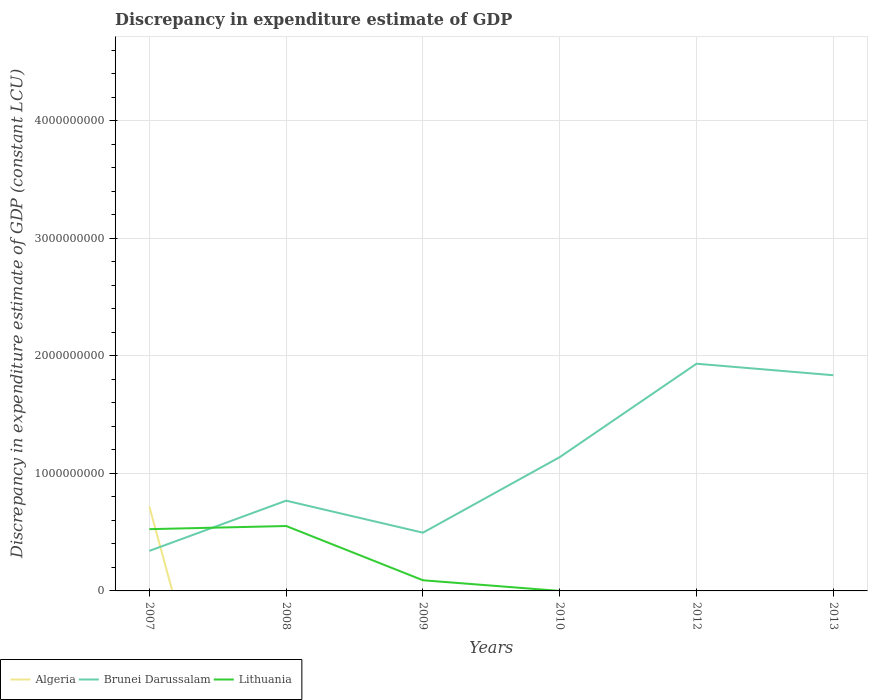How many different coloured lines are there?
Your answer should be very brief. 3. Does the line corresponding to Lithuania intersect with the line corresponding to Brunei Darussalam?
Your response must be concise. Yes. Is the number of lines equal to the number of legend labels?
Your answer should be compact. No. Across all years, what is the maximum discrepancy in expenditure estimate of GDP in Brunei Darussalam?
Make the answer very short. 3.41e+08. What is the total discrepancy in expenditure estimate of GDP in Brunei Darussalam in the graph?
Your response must be concise. -1.49e+09. What is the difference between the highest and the second highest discrepancy in expenditure estimate of GDP in Lithuania?
Offer a terse response. 5.52e+08. What is the difference between the highest and the lowest discrepancy in expenditure estimate of GDP in Lithuania?
Provide a short and direct response. 2. Is the discrepancy in expenditure estimate of GDP in Brunei Darussalam strictly greater than the discrepancy in expenditure estimate of GDP in Lithuania over the years?
Give a very brief answer. No. How many lines are there?
Ensure brevity in your answer.  3. What is the difference between two consecutive major ticks on the Y-axis?
Ensure brevity in your answer.  1.00e+09. Are the values on the major ticks of Y-axis written in scientific E-notation?
Offer a terse response. No. Does the graph contain grids?
Provide a short and direct response. Yes. Where does the legend appear in the graph?
Your response must be concise. Bottom left. How many legend labels are there?
Make the answer very short. 3. How are the legend labels stacked?
Your answer should be compact. Horizontal. What is the title of the graph?
Your answer should be very brief. Discrepancy in expenditure estimate of GDP. Does "Moldova" appear as one of the legend labels in the graph?
Your answer should be compact. No. What is the label or title of the X-axis?
Make the answer very short. Years. What is the label or title of the Y-axis?
Offer a terse response. Discrepancy in expenditure estimate of GDP (constant LCU). What is the Discrepancy in expenditure estimate of GDP (constant LCU) of Algeria in 2007?
Provide a short and direct response. 7.17e+08. What is the Discrepancy in expenditure estimate of GDP (constant LCU) of Brunei Darussalam in 2007?
Ensure brevity in your answer.  3.41e+08. What is the Discrepancy in expenditure estimate of GDP (constant LCU) in Lithuania in 2007?
Ensure brevity in your answer.  5.26e+08. What is the Discrepancy in expenditure estimate of GDP (constant LCU) in Brunei Darussalam in 2008?
Make the answer very short. 7.68e+08. What is the Discrepancy in expenditure estimate of GDP (constant LCU) of Lithuania in 2008?
Keep it short and to the point. 5.52e+08. What is the Discrepancy in expenditure estimate of GDP (constant LCU) of Brunei Darussalam in 2009?
Offer a terse response. 4.96e+08. What is the Discrepancy in expenditure estimate of GDP (constant LCU) of Lithuania in 2009?
Give a very brief answer. 9.07e+07. What is the Discrepancy in expenditure estimate of GDP (constant LCU) of Algeria in 2010?
Offer a very short reply. 0. What is the Discrepancy in expenditure estimate of GDP (constant LCU) in Brunei Darussalam in 2010?
Your answer should be very brief. 1.14e+09. What is the Discrepancy in expenditure estimate of GDP (constant LCU) in Algeria in 2012?
Offer a very short reply. 0. What is the Discrepancy in expenditure estimate of GDP (constant LCU) of Brunei Darussalam in 2012?
Offer a very short reply. 1.93e+09. What is the Discrepancy in expenditure estimate of GDP (constant LCU) in Lithuania in 2012?
Your answer should be compact. 0. What is the Discrepancy in expenditure estimate of GDP (constant LCU) of Algeria in 2013?
Provide a succinct answer. 0. What is the Discrepancy in expenditure estimate of GDP (constant LCU) of Brunei Darussalam in 2013?
Give a very brief answer. 1.84e+09. What is the Discrepancy in expenditure estimate of GDP (constant LCU) of Lithuania in 2013?
Your answer should be compact. 0. Across all years, what is the maximum Discrepancy in expenditure estimate of GDP (constant LCU) of Algeria?
Offer a terse response. 7.17e+08. Across all years, what is the maximum Discrepancy in expenditure estimate of GDP (constant LCU) in Brunei Darussalam?
Offer a very short reply. 1.93e+09. Across all years, what is the maximum Discrepancy in expenditure estimate of GDP (constant LCU) of Lithuania?
Provide a succinct answer. 5.52e+08. Across all years, what is the minimum Discrepancy in expenditure estimate of GDP (constant LCU) in Brunei Darussalam?
Provide a short and direct response. 3.41e+08. Across all years, what is the minimum Discrepancy in expenditure estimate of GDP (constant LCU) in Lithuania?
Provide a short and direct response. 0. What is the total Discrepancy in expenditure estimate of GDP (constant LCU) in Algeria in the graph?
Offer a terse response. 7.17e+08. What is the total Discrepancy in expenditure estimate of GDP (constant LCU) in Brunei Darussalam in the graph?
Your response must be concise. 6.51e+09. What is the total Discrepancy in expenditure estimate of GDP (constant LCU) of Lithuania in the graph?
Give a very brief answer. 1.17e+09. What is the difference between the Discrepancy in expenditure estimate of GDP (constant LCU) in Brunei Darussalam in 2007 and that in 2008?
Provide a succinct answer. -4.27e+08. What is the difference between the Discrepancy in expenditure estimate of GDP (constant LCU) in Lithuania in 2007 and that in 2008?
Make the answer very short. -2.67e+07. What is the difference between the Discrepancy in expenditure estimate of GDP (constant LCU) in Brunei Darussalam in 2007 and that in 2009?
Make the answer very short. -1.55e+08. What is the difference between the Discrepancy in expenditure estimate of GDP (constant LCU) of Lithuania in 2007 and that in 2009?
Your answer should be compact. 4.35e+08. What is the difference between the Discrepancy in expenditure estimate of GDP (constant LCU) in Brunei Darussalam in 2007 and that in 2010?
Keep it short and to the point. -7.98e+08. What is the difference between the Discrepancy in expenditure estimate of GDP (constant LCU) of Lithuania in 2007 and that in 2010?
Keep it short and to the point. 5.26e+08. What is the difference between the Discrepancy in expenditure estimate of GDP (constant LCU) of Brunei Darussalam in 2007 and that in 2012?
Give a very brief answer. -1.59e+09. What is the difference between the Discrepancy in expenditure estimate of GDP (constant LCU) of Brunei Darussalam in 2007 and that in 2013?
Offer a very short reply. -1.49e+09. What is the difference between the Discrepancy in expenditure estimate of GDP (constant LCU) in Brunei Darussalam in 2008 and that in 2009?
Provide a short and direct response. 2.72e+08. What is the difference between the Discrepancy in expenditure estimate of GDP (constant LCU) in Lithuania in 2008 and that in 2009?
Keep it short and to the point. 4.62e+08. What is the difference between the Discrepancy in expenditure estimate of GDP (constant LCU) in Brunei Darussalam in 2008 and that in 2010?
Offer a very short reply. -3.71e+08. What is the difference between the Discrepancy in expenditure estimate of GDP (constant LCU) of Lithuania in 2008 and that in 2010?
Make the answer very short. 5.52e+08. What is the difference between the Discrepancy in expenditure estimate of GDP (constant LCU) of Brunei Darussalam in 2008 and that in 2012?
Offer a terse response. -1.17e+09. What is the difference between the Discrepancy in expenditure estimate of GDP (constant LCU) in Brunei Darussalam in 2008 and that in 2013?
Make the answer very short. -1.07e+09. What is the difference between the Discrepancy in expenditure estimate of GDP (constant LCU) of Brunei Darussalam in 2009 and that in 2010?
Your response must be concise. -6.43e+08. What is the difference between the Discrepancy in expenditure estimate of GDP (constant LCU) in Lithuania in 2009 and that in 2010?
Give a very brief answer. 9.07e+07. What is the difference between the Discrepancy in expenditure estimate of GDP (constant LCU) of Brunei Darussalam in 2009 and that in 2012?
Offer a terse response. -1.44e+09. What is the difference between the Discrepancy in expenditure estimate of GDP (constant LCU) in Brunei Darussalam in 2009 and that in 2013?
Offer a terse response. -1.34e+09. What is the difference between the Discrepancy in expenditure estimate of GDP (constant LCU) of Brunei Darussalam in 2010 and that in 2012?
Offer a very short reply. -7.95e+08. What is the difference between the Discrepancy in expenditure estimate of GDP (constant LCU) of Brunei Darussalam in 2010 and that in 2013?
Keep it short and to the point. -6.97e+08. What is the difference between the Discrepancy in expenditure estimate of GDP (constant LCU) of Brunei Darussalam in 2012 and that in 2013?
Keep it short and to the point. 9.79e+07. What is the difference between the Discrepancy in expenditure estimate of GDP (constant LCU) in Algeria in 2007 and the Discrepancy in expenditure estimate of GDP (constant LCU) in Brunei Darussalam in 2008?
Ensure brevity in your answer.  -5.05e+07. What is the difference between the Discrepancy in expenditure estimate of GDP (constant LCU) in Algeria in 2007 and the Discrepancy in expenditure estimate of GDP (constant LCU) in Lithuania in 2008?
Provide a succinct answer. 1.65e+08. What is the difference between the Discrepancy in expenditure estimate of GDP (constant LCU) of Brunei Darussalam in 2007 and the Discrepancy in expenditure estimate of GDP (constant LCU) of Lithuania in 2008?
Provide a short and direct response. -2.12e+08. What is the difference between the Discrepancy in expenditure estimate of GDP (constant LCU) of Algeria in 2007 and the Discrepancy in expenditure estimate of GDP (constant LCU) of Brunei Darussalam in 2009?
Ensure brevity in your answer.  2.22e+08. What is the difference between the Discrepancy in expenditure estimate of GDP (constant LCU) in Algeria in 2007 and the Discrepancy in expenditure estimate of GDP (constant LCU) in Lithuania in 2009?
Provide a short and direct response. 6.27e+08. What is the difference between the Discrepancy in expenditure estimate of GDP (constant LCU) in Brunei Darussalam in 2007 and the Discrepancy in expenditure estimate of GDP (constant LCU) in Lithuania in 2009?
Your answer should be compact. 2.50e+08. What is the difference between the Discrepancy in expenditure estimate of GDP (constant LCU) in Algeria in 2007 and the Discrepancy in expenditure estimate of GDP (constant LCU) in Brunei Darussalam in 2010?
Your answer should be compact. -4.21e+08. What is the difference between the Discrepancy in expenditure estimate of GDP (constant LCU) in Algeria in 2007 and the Discrepancy in expenditure estimate of GDP (constant LCU) in Lithuania in 2010?
Give a very brief answer. 7.17e+08. What is the difference between the Discrepancy in expenditure estimate of GDP (constant LCU) in Brunei Darussalam in 2007 and the Discrepancy in expenditure estimate of GDP (constant LCU) in Lithuania in 2010?
Your response must be concise. 3.41e+08. What is the difference between the Discrepancy in expenditure estimate of GDP (constant LCU) of Algeria in 2007 and the Discrepancy in expenditure estimate of GDP (constant LCU) of Brunei Darussalam in 2012?
Your answer should be compact. -1.22e+09. What is the difference between the Discrepancy in expenditure estimate of GDP (constant LCU) of Algeria in 2007 and the Discrepancy in expenditure estimate of GDP (constant LCU) of Brunei Darussalam in 2013?
Your response must be concise. -1.12e+09. What is the difference between the Discrepancy in expenditure estimate of GDP (constant LCU) of Brunei Darussalam in 2008 and the Discrepancy in expenditure estimate of GDP (constant LCU) of Lithuania in 2009?
Make the answer very short. 6.77e+08. What is the difference between the Discrepancy in expenditure estimate of GDP (constant LCU) in Brunei Darussalam in 2008 and the Discrepancy in expenditure estimate of GDP (constant LCU) in Lithuania in 2010?
Provide a succinct answer. 7.68e+08. What is the difference between the Discrepancy in expenditure estimate of GDP (constant LCU) in Brunei Darussalam in 2009 and the Discrepancy in expenditure estimate of GDP (constant LCU) in Lithuania in 2010?
Offer a terse response. 4.95e+08. What is the average Discrepancy in expenditure estimate of GDP (constant LCU) in Algeria per year?
Offer a very short reply. 1.20e+08. What is the average Discrepancy in expenditure estimate of GDP (constant LCU) in Brunei Darussalam per year?
Offer a terse response. 1.09e+09. What is the average Discrepancy in expenditure estimate of GDP (constant LCU) of Lithuania per year?
Your answer should be compact. 1.95e+08. In the year 2007, what is the difference between the Discrepancy in expenditure estimate of GDP (constant LCU) of Algeria and Discrepancy in expenditure estimate of GDP (constant LCU) of Brunei Darussalam?
Keep it short and to the point. 3.77e+08. In the year 2007, what is the difference between the Discrepancy in expenditure estimate of GDP (constant LCU) in Algeria and Discrepancy in expenditure estimate of GDP (constant LCU) in Lithuania?
Provide a short and direct response. 1.92e+08. In the year 2007, what is the difference between the Discrepancy in expenditure estimate of GDP (constant LCU) in Brunei Darussalam and Discrepancy in expenditure estimate of GDP (constant LCU) in Lithuania?
Give a very brief answer. -1.85e+08. In the year 2008, what is the difference between the Discrepancy in expenditure estimate of GDP (constant LCU) in Brunei Darussalam and Discrepancy in expenditure estimate of GDP (constant LCU) in Lithuania?
Offer a terse response. 2.16e+08. In the year 2009, what is the difference between the Discrepancy in expenditure estimate of GDP (constant LCU) in Brunei Darussalam and Discrepancy in expenditure estimate of GDP (constant LCU) in Lithuania?
Offer a very short reply. 4.05e+08. In the year 2010, what is the difference between the Discrepancy in expenditure estimate of GDP (constant LCU) of Brunei Darussalam and Discrepancy in expenditure estimate of GDP (constant LCU) of Lithuania?
Give a very brief answer. 1.14e+09. What is the ratio of the Discrepancy in expenditure estimate of GDP (constant LCU) in Brunei Darussalam in 2007 to that in 2008?
Offer a terse response. 0.44. What is the ratio of the Discrepancy in expenditure estimate of GDP (constant LCU) in Lithuania in 2007 to that in 2008?
Offer a terse response. 0.95. What is the ratio of the Discrepancy in expenditure estimate of GDP (constant LCU) of Brunei Darussalam in 2007 to that in 2009?
Make the answer very short. 0.69. What is the ratio of the Discrepancy in expenditure estimate of GDP (constant LCU) of Lithuania in 2007 to that in 2009?
Ensure brevity in your answer.  5.8. What is the ratio of the Discrepancy in expenditure estimate of GDP (constant LCU) of Brunei Darussalam in 2007 to that in 2010?
Keep it short and to the point. 0.3. What is the ratio of the Discrepancy in expenditure estimate of GDP (constant LCU) in Lithuania in 2007 to that in 2010?
Keep it short and to the point. 5.26e+06. What is the ratio of the Discrepancy in expenditure estimate of GDP (constant LCU) of Brunei Darussalam in 2007 to that in 2012?
Give a very brief answer. 0.18. What is the ratio of the Discrepancy in expenditure estimate of GDP (constant LCU) in Brunei Darussalam in 2007 to that in 2013?
Make the answer very short. 0.19. What is the ratio of the Discrepancy in expenditure estimate of GDP (constant LCU) of Brunei Darussalam in 2008 to that in 2009?
Your response must be concise. 1.55. What is the ratio of the Discrepancy in expenditure estimate of GDP (constant LCU) in Lithuania in 2008 to that in 2009?
Offer a terse response. 6.09. What is the ratio of the Discrepancy in expenditure estimate of GDP (constant LCU) of Brunei Darussalam in 2008 to that in 2010?
Make the answer very short. 0.67. What is the ratio of the Discrepancy in expenditure estimate of GDP (constant LCU) in Lithuania in 2008 to that in 2010?
Offer a very short reply. 5.52e+06. What is the ratio of the Discrepancy in expenditure estimate of GDP (constant LCU) in Brunei Darussalam in 2008 to that in 2012?
Your response must be concise. 0.4. What is the ratio of the Discrepancy in expenditure estimate of GDP (constant LCU) in Brunei Darussalam in 2008 to that in 2013?
Your answer should be very brief. 0.42. What is the ratio of the Discrepancy in expenditure estimate of GDP (constant LCU) of Brunei Darussalam in 2009 to that in 2010?
Provide a succinct answer. 0.44. What is the ratio of the Discrepancy in expenditure estimate of GDP (constant LCU) of Lithuania in 2009 to that in 2010?
Ensure brevity in your answer.  9.07e+05. What is the ratio of the Discrepancy in expenditure estimate of GDP (constant LCU) of Brunei Darussalam in 2009 to that in 2012?
Provide a succinct answer. 0.26. What is the ratio of the Discrepancy in expenditure estimate of GDP (constant LCU) of Brunei Darussalam in 2009 to that in 2013?
Offer a terse response. 0.27. What is the ratio of the Discrepancy in expenditure estimate of GDP (constant LCU) in Brunei Darussalam in 2010 to that in 2012?
Give a very brief answer. 0.59. What is the ratio of the Discrepancy in expenditure estimate of GDP (constant LCU) of Brunei Darussalam in 2010 to that in 2013?
Your answer should be very brief. 0.62. What is the ratio of the Discrepancy in expenditure estimate of GDP (constant LCU) of Brunei Darussalam in 2012 to that in 2013?
Give a very brief answer. 1.05. What is the difference between the highest and the second highest Discrepancy in expenditure estimate of GDP (constant LCU) in Brunei Darussalam?
Offer a very short reply. 9.79e+07. What is the difference between the highest and the second highest Discrepancy in expenditure estimate of GDP (constant LCU) of Lithuania?
Make the answer very short. 2.67e+07. What is the difference between the highest and the lowest Discrepancy in expenditure estimate of GDP (constant LCU) of Algeria?
Give a very brief answer. 7.17e+08. What is the difference between the highest and the lowest Discrepancy in expenditure estimate of GDP (constant LCU) in Brunei Darussalam?
Your response must be concise. 1.59e+09. What is the difference between the highest and the lowest Discrepancy in expenditure estimate of GDP (constant LCU) in Lithuania?
Keep it short and to the point. 5.52e+08. 